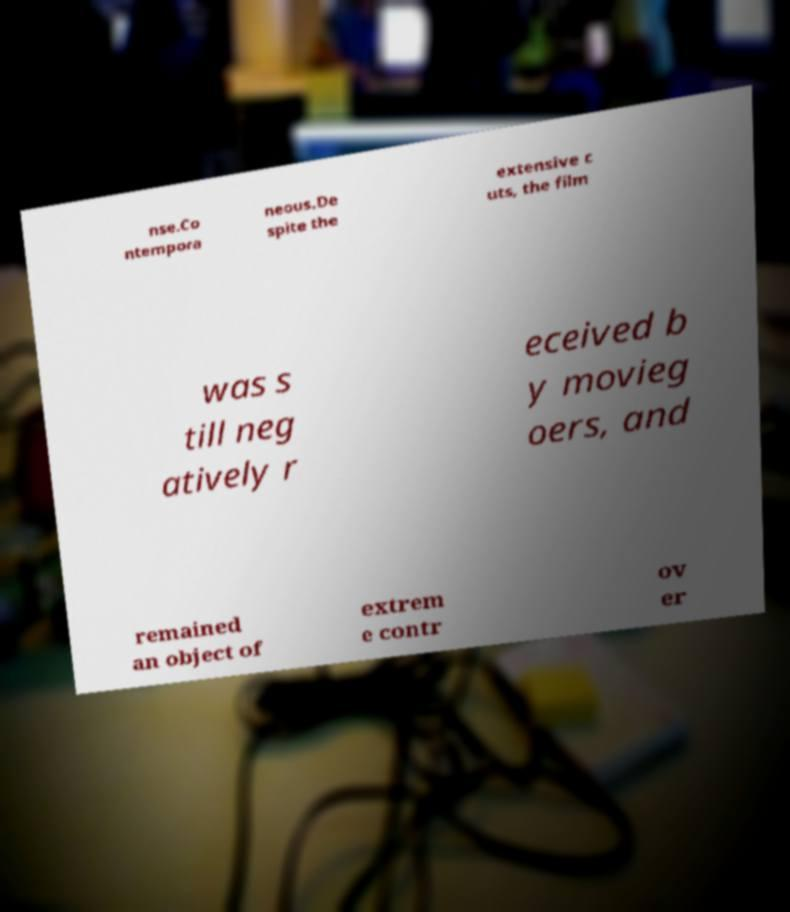Could you assist in decoding the text presented in this image and type it out clearly? nse.Co ntempora neous.De spite the extensive c uts, the film was s till neg atively r eceived b y movieg oers, and remained an object of extrem e contr ov er 